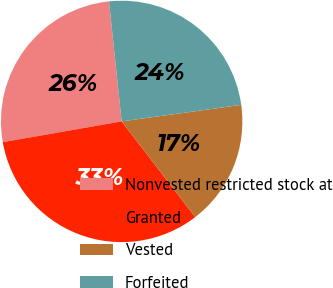Convert chart. <chart><loc_0><loc_0><loc_500><loc_500><pie_chart><fcel>Nonvested restricted stock at<fcel>Granted<fcel>Vested<fcel>Forfeited<nl><fcel>26.08%<fcel>32.69%<fcel>16.75%<fcel>24.49%<nl></chart> 